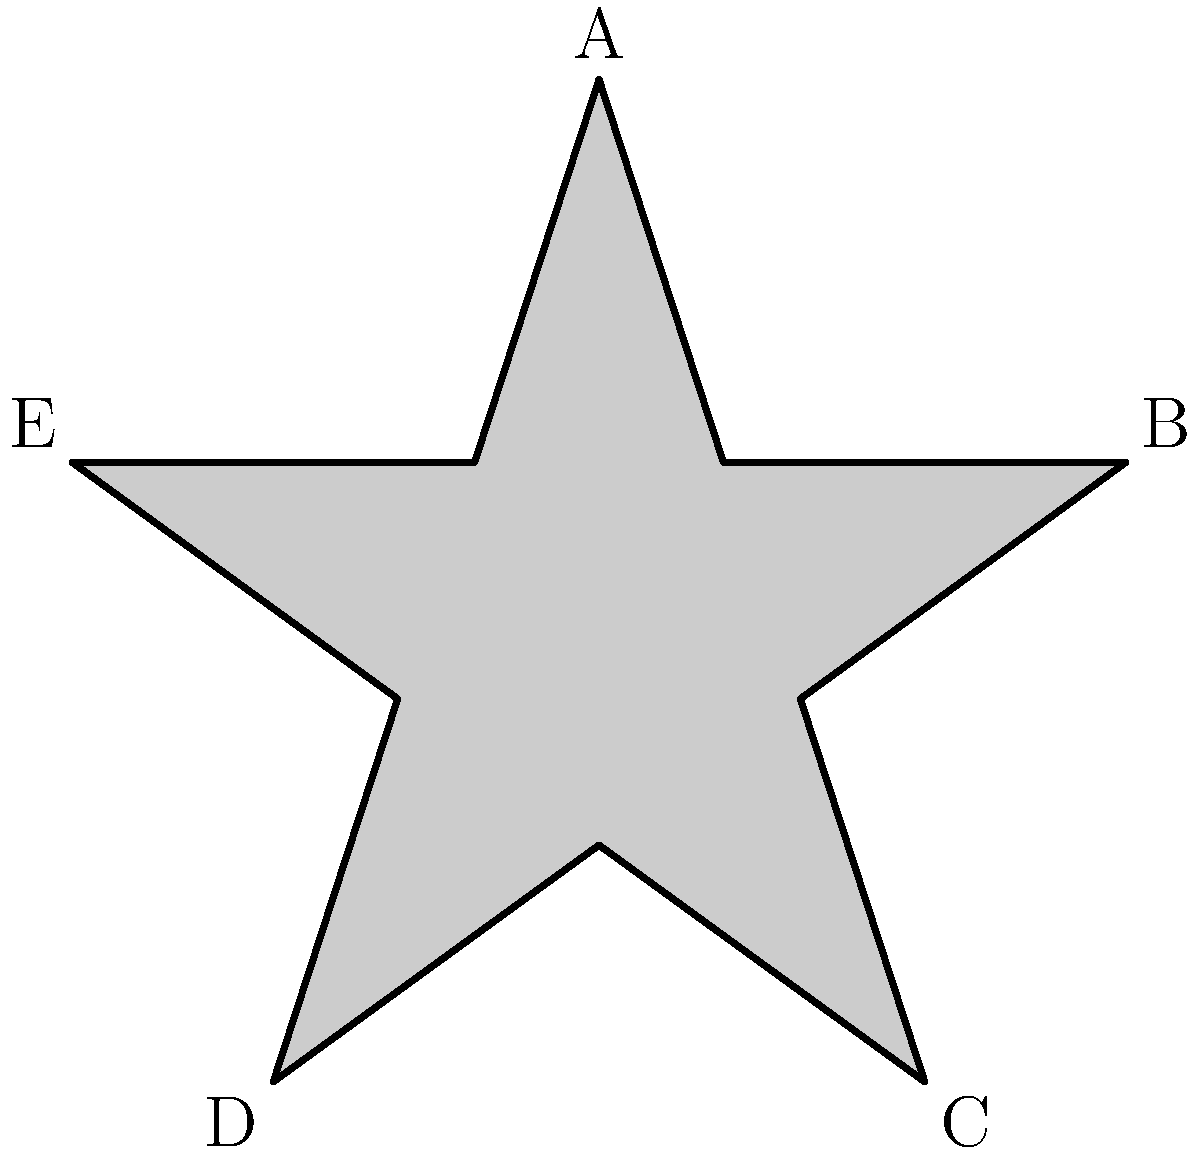The image shows a five-pointed star, commonly used in military insignias. If we consider the rotational symmetries of this star, which form a group under composition, what is the order of this group? Additionally, what is the smallest positive angle of rotation (in degrees) that maps the star onto itself? To solve this problem, we need to understand the concept of rotational symmetry and apply it to the given star shape:

1. Rotational symmetry occurs when an object can be rotated about its center and appear unchanged.

2. For a regular five-pointed star:
   a. It has 5 identical points (labeled A, B, C, D, E in the diagram).
   b. Each rotation that maps the star onto itself must move each point to another point's position.

3. The possible rotations are:
   - 0° (identity rotation)
   - 72° (rotate one-fifth of a full turn)
   - 144° (rotate two-fifths of a full turn)
   - 216° (rotate three-fifths of a full turn)
   - 288° (rotate four-fifths of a full turn)

4. The order of the group is the number of distinct rotations, which is 5.

5. The smallest positive angle of rotation that maps the star onto itself is 360° ÷ 5 = 72°.

Therefore, the order of the rotational symmetry group is 5, and the smallest positive angle of rotation is 72°.
Answer: Order: 5, Smallest angle: 72° 